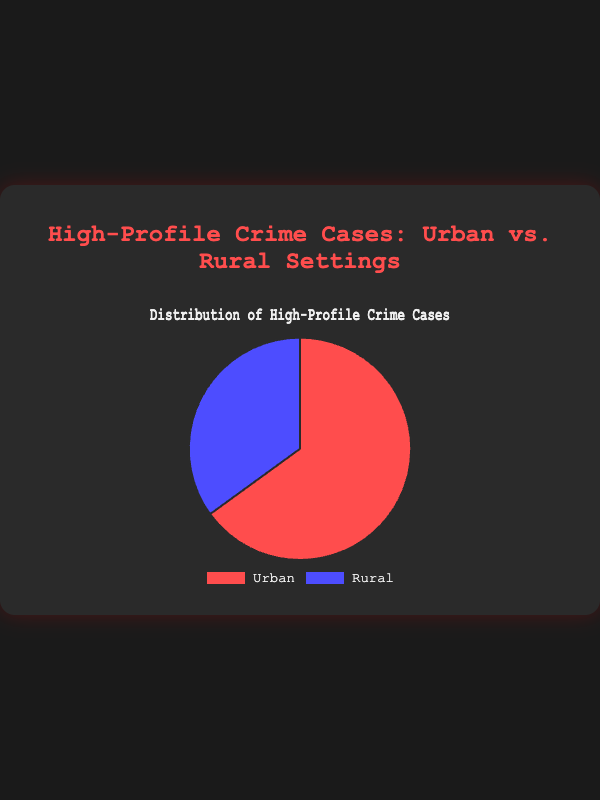What is the percentage of high-profile crime cases in urban settings? To find the percentage of high-profile crime cases in urban settings, look at the data sections on the pie chart. The urban section is labeled as "Urban" and represents 65% of the cases.
Answer: 65% What is the percentage difference between urban and rural high-profile crime cases? The chart shows that urban settings have 65% of the cases, and rural settings have 35%. To find the percentage difference, subtract 35% from 65%.
Answer: 30% What proportion of high-profile crime cases occur in rural settings compared to urban settings? The chart indicates 65% of high-profile crime cases are urban and 35% are rural. To find the proportion, divide 35% (rural) by 65% (urban) and simplify if necessary: 35/65 = 0.54, which is approximately one third or 35/65.
Answer: 0.54 or 35/65 Is the percentage of high-profile crime cases higher in urban settings or rural settings? The chart shows that urban settings account for 65% of high-profile crime cases while rural settings account for 35%. 65% is greater than 35%.
Answer: Urban settings How much larger is the urban section compared to the rural section in the pie chart? The urban section occupies 65% of the pie chart whereas the rural section takes up 35%. To find out how much larger the urban section is, subtract 35% from 65%.
Answer: 30% What is the total percentage of high-profile crime cases depicted in the pie chart? The pie chart depicts two categories: urban and rural, making up 65% and 35% respectively. Summing these values gives 65% + 35% = 100%.
Answer: 100% What color represents the urban high-profile crime cases? In the pie chart, the urban high-profile crime cases section is colored red.
Answer: Red Is there an equal distribution of high-profile crime cases between urban and rural settings? To determine if there's an equal distribution, see if both sections of the pie chart are 50%. The urban cases are 65%, and rural cases are 35%, which shows an unequal distribution.
Answer: No If the number of rural high-profile crime cases increased by 10%, what would be the new percentage for rural cases? Initially, rural settings have 35% of the cases. A 10% increase of 35% means an absolute increase of 0.10 * 35% = 3.5%. Adding this to the original, 35% + 3.5% = 38.5%.
Answer: 38.5% What can be inferred about the trend in high-profile crime cases based on the chart? The chart shows that a higher percentage of high-profile crime cases occur in urban settings (65%) compared to rural settings (35%), suggesting a trend towards more high-profile crime cases happening in urban areas.
Answer: More in urban areas 